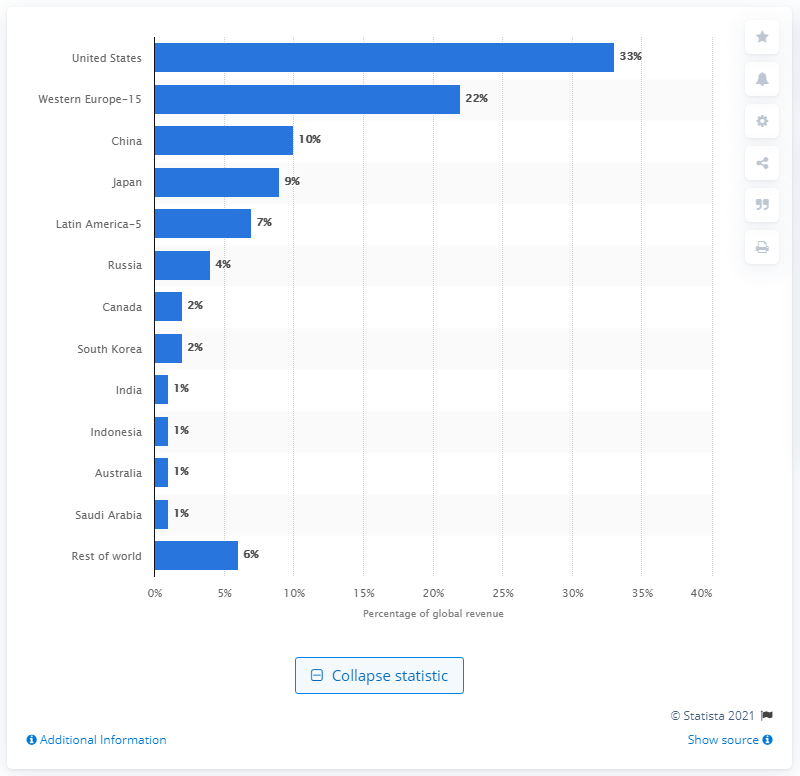Indicate a few pertinent items in this graphic. Australia had one of the lowest single shares among the listed countries. The United States held 33% of global pharmaceutical revenue in 2021. 